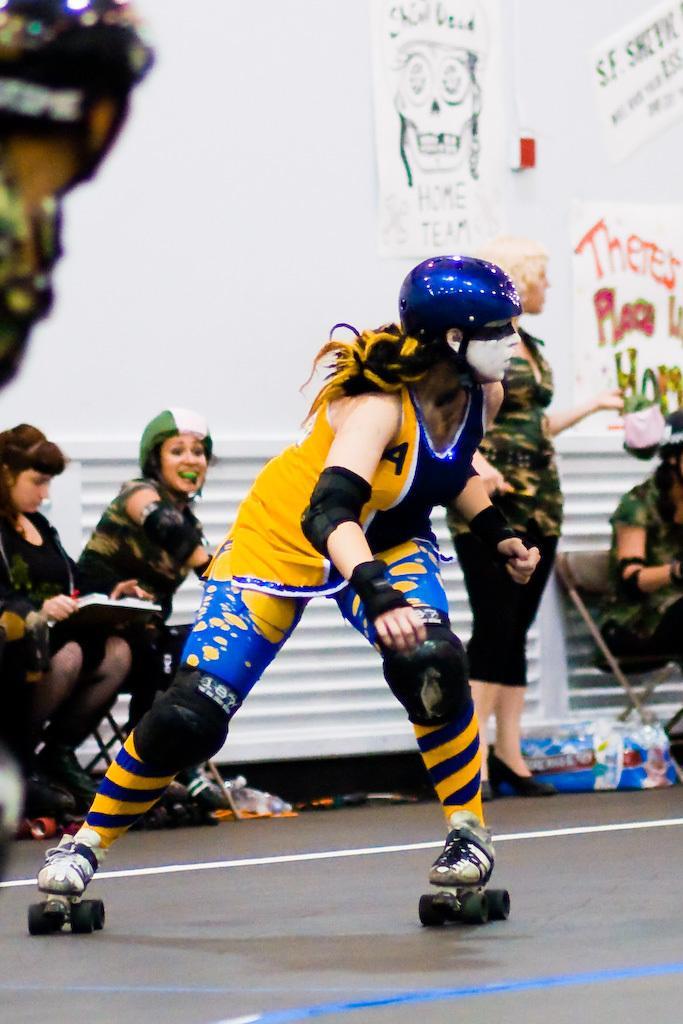How would you summarize this image in a sentence or two? In this picture there is a girl in the center of the image, she is skating and there are other girls in the background area of the image, there are posters on the wall on the right side of the image. 